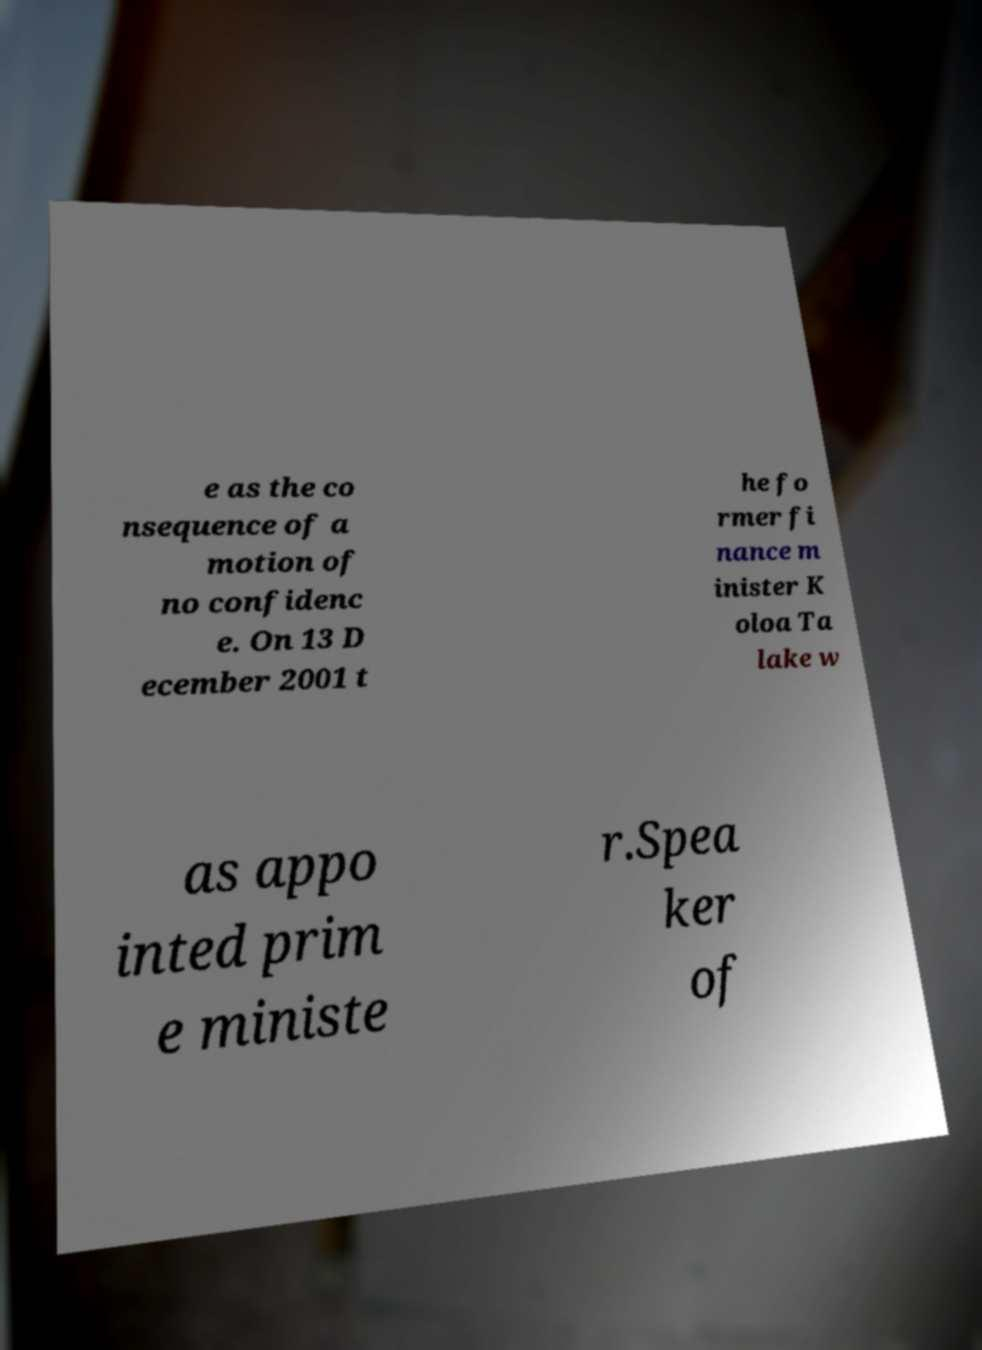Please read and relay the text visible in this image. What does it say? e as the co nsequence of a motion of no confidenc e. On 13 D ecember 2001 t he fo rmer fi nance m inister K oloa Ta lake w as appo inted prim e ministe r.Spea ker of 